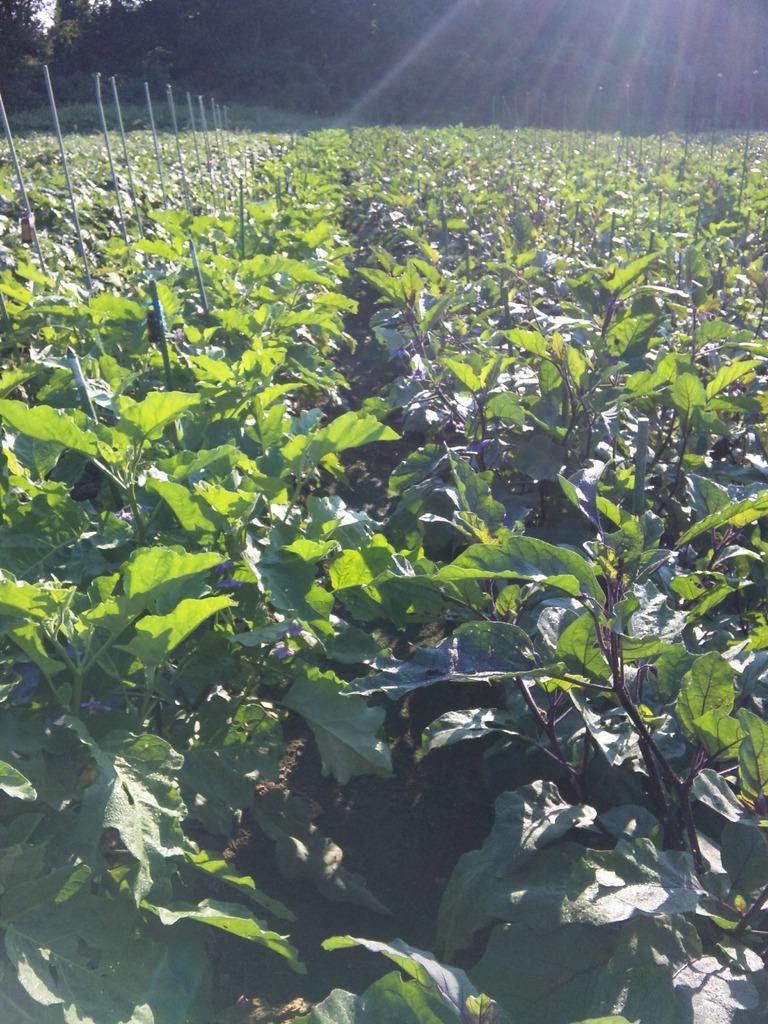In one or two sentences, can you explain what this image depicts? In this picture we can see plants, poles and in the background we can see trees. 